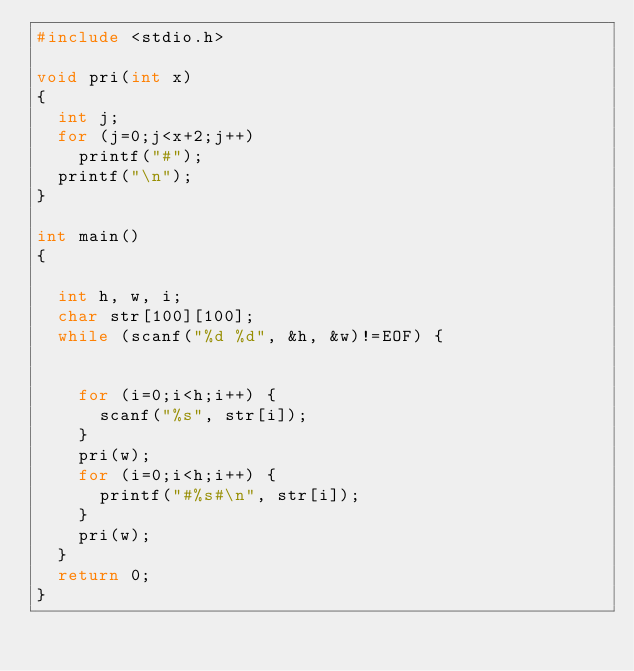<code> <loc_0><loc_0><loc_500><loc_500><_C_>#include <stdio.h>

void pri(int x)
{
	int j;
	for (j=0;j<x+2;j++)
		printf("#");
	printf("\n");
}

int main()
{

	int h, w, i;
	char str[100][100];
	while (scanf("%d %d", &h, &w)!=EOF) {
		
		
		for (i=0;i<h;i++) {
			scanf("%s", str[i]);
		}
		pri(w);
		for (i=0;i<h;i++) {
			printf("#%s#\n", str[i]);
		}
		pri(w);
	}
	return 0;
}


 </code> 